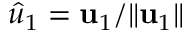<formula> <loc_0><loc_0><loc_500><loc_500>\hat { u } _ { 1 } = u _ { 1 } / \| u _ { 1 } \|</formula> 